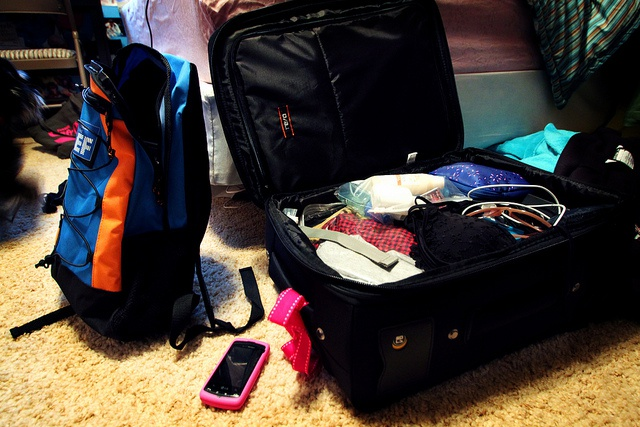Describe the objects in this image and their specific colors. I can see suitcase in black, ivory, gray, and beige tones, backpack in black, navy, blue, and red tones, bed in black, maroon, brown, and teal tones, and cell phone in black, violet, and brown tones in this image. 